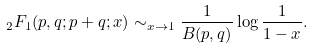Convert formula to latex. <formula><loc_0><loc_0><loc_500><loc_500>\ _ { 2 } F _ { 1 } ( p , q ; p + q ; x ) \sim _ { x \rightarrow 1 } \frac { 1 } { B ( p , q ) } \log \frac { 1 } { 1 - x } .</formula> 